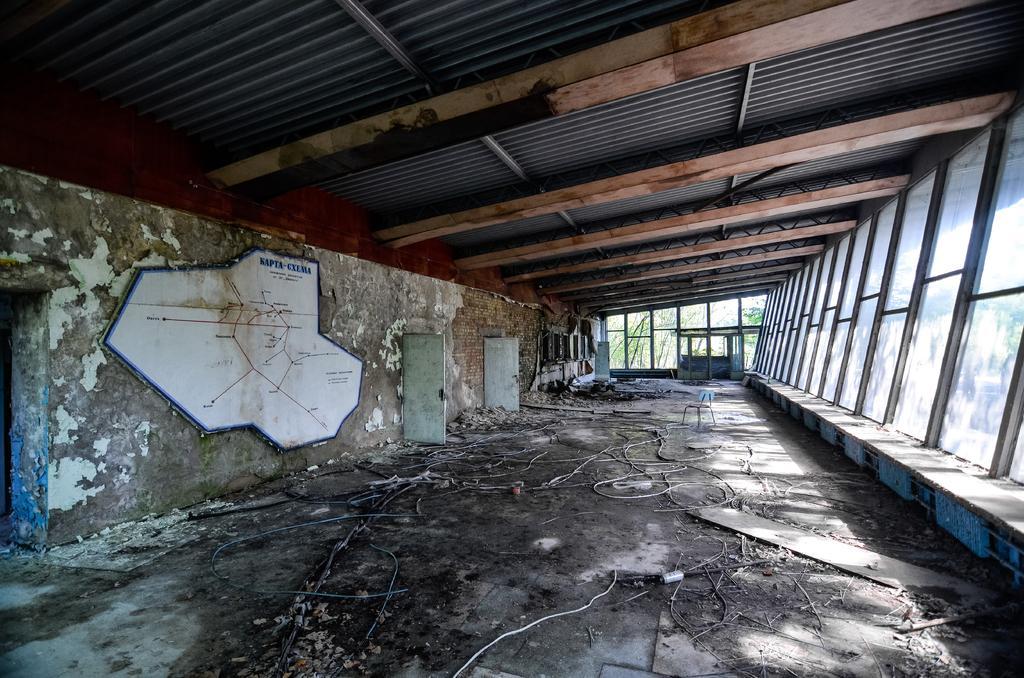Describe this image in one or two sentences. This is clicked inside a abandoned building with wires and dust all over the place, there are windows on the right side and the ceiling is of iron sheets. 